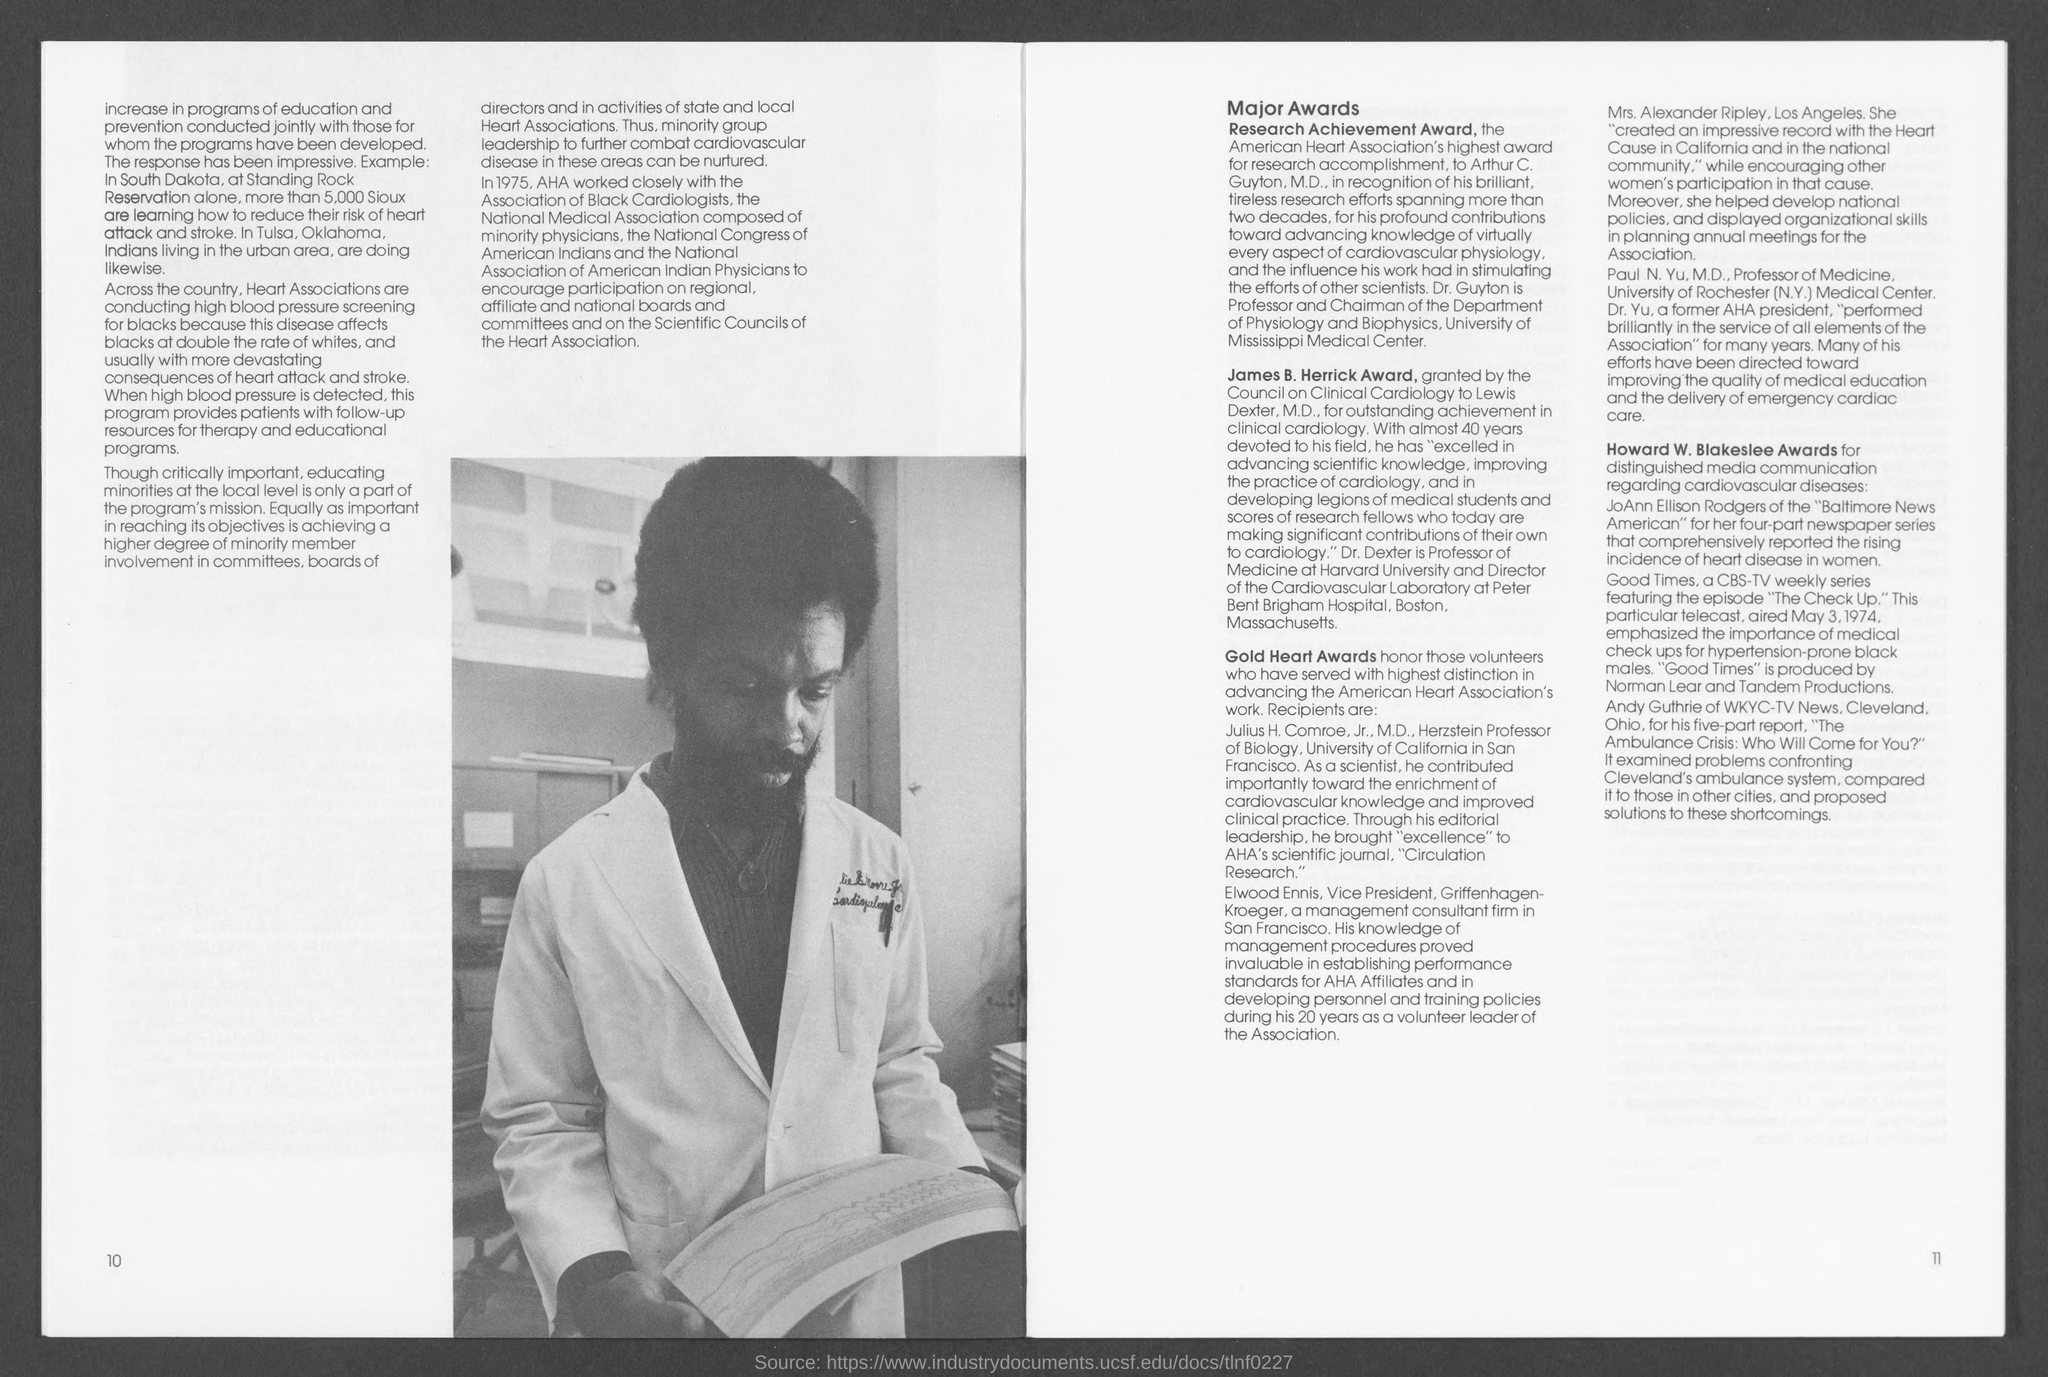What is the number at bottom-left corner of the page ?
Offer a terse response. 10. What is the number at bottom- right corner of the page ?
Keep it short and to the point. 11. 